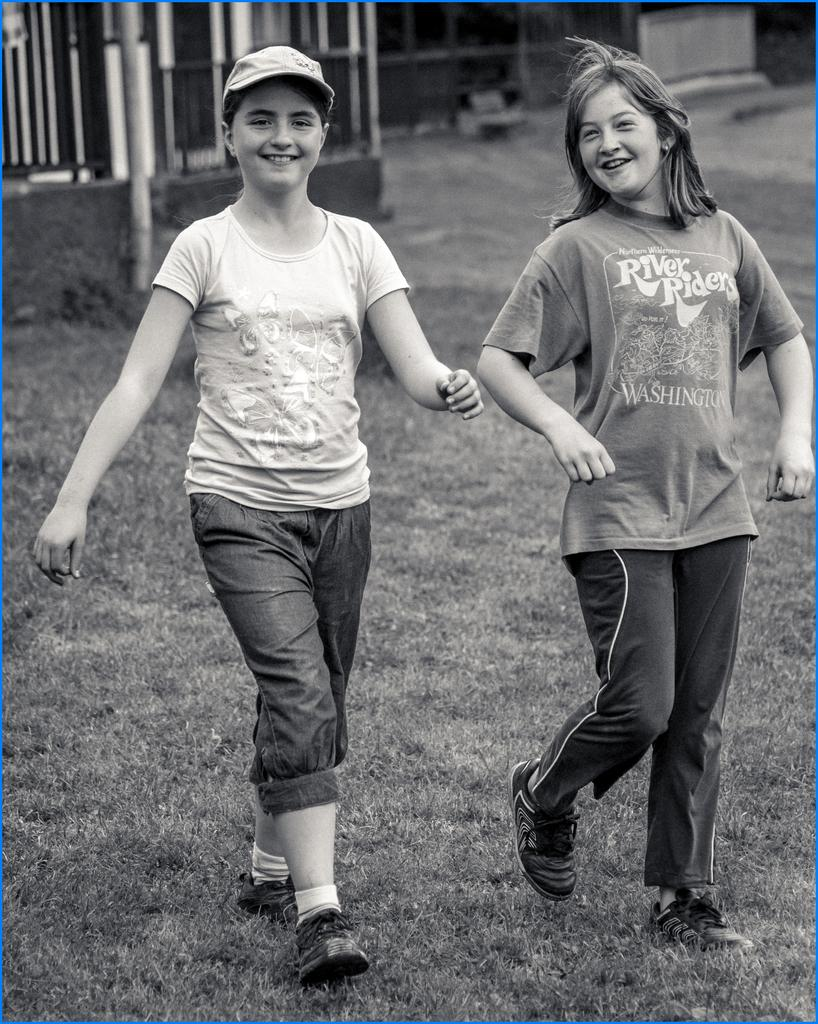How many children are in the image? There are two children in the image. What are the children wearing? The children are wearing t-shirts in different colors. What expression do the children have? The children are smiling. What are the children doing in the image? The children are walking on the ground. What type of vegetation is on the ground? There is grass on the ground. What can be seen in the background of the image? There is a fence and a pole in the background of the image. What holiday advice can be seen on the pole in the background of the image? There is no holiday advice present on the pole in the background of the image. Is there a fireman in the image helping the children walk on the grass? There is no fireman present in the image; the children are walking on the grass without assistance. 